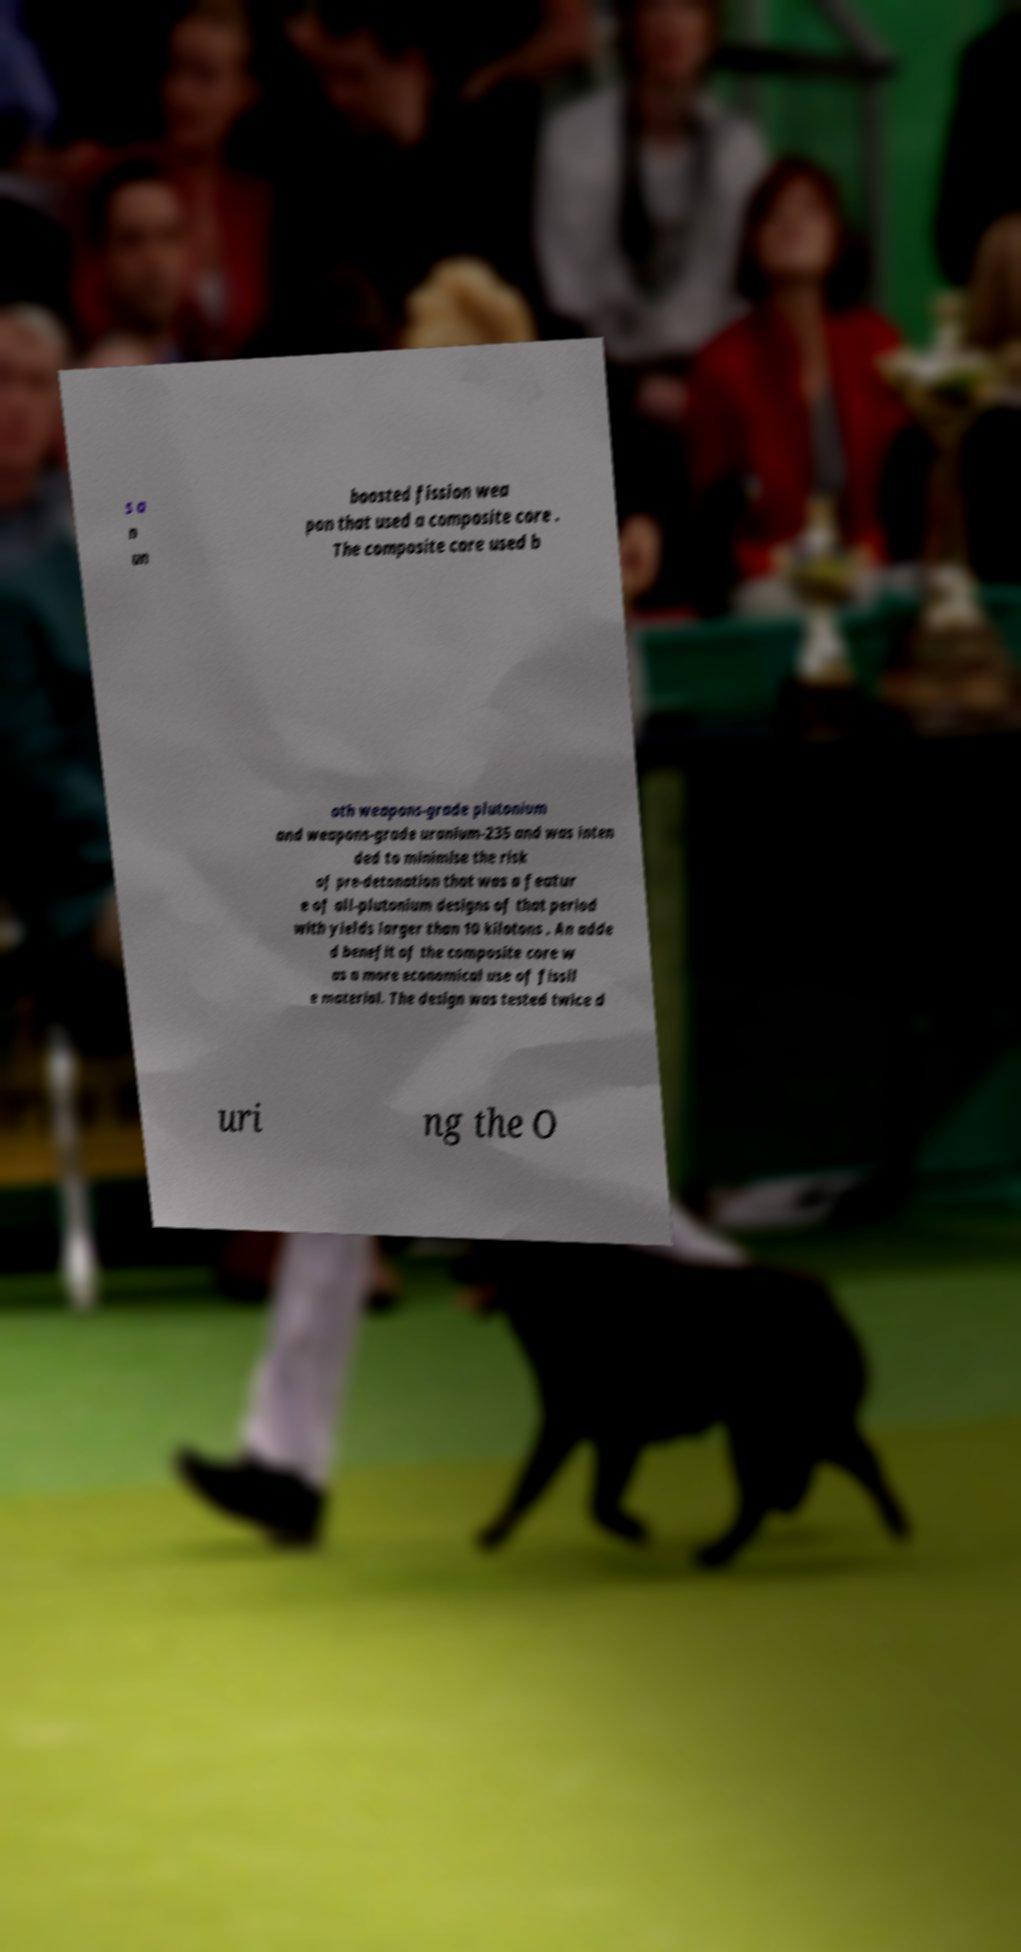Please read and relay the text visible in this image. What does it say? s a n un boosted fission wea pon that used a composite core . The composite core used b oth weapons-grade plutonium and weapons-grade uranium-235 and was inten ded to minimise the risk of pre-detonation that was a featur e of all-plutonium designs of that period with yields larger than 10 kilotons . An adde d benefit of the composite core w as a more economical use of fissil e material. The design was tested twice d uri ng the O 